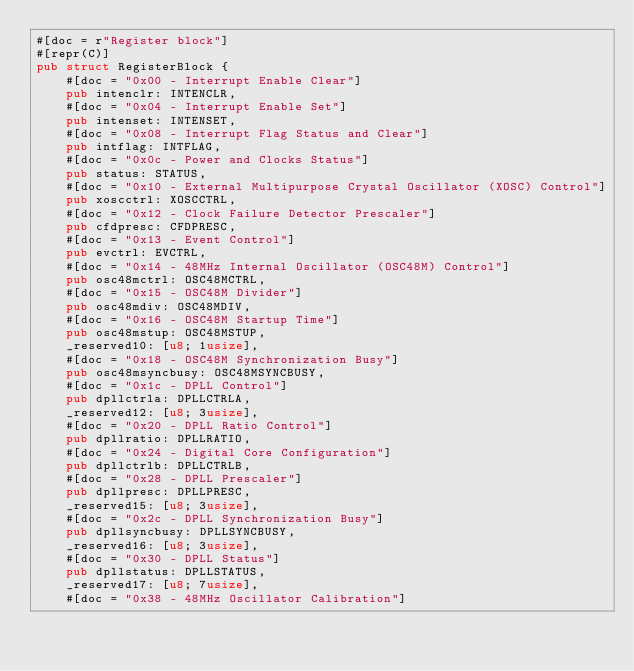<code> <loc_0><loc_0><loc_500><loc_500><_Rust_>#[doc = r"Register block"]
#[repr(C)]
pub struct RegisterBlock {
    #[doc = "0x00 - Interrupt Enable Clear"]
    pub intenclr: INTENCLR,
    #[doc = "0x04 - Interrupt Enable Set"]
    pub intenset: INTENSET,
    #[doc = "0x08 - Interrupt Flag Status and Clear"]
    pub intflag: INTFLAG,
    #[doc = "0x0c - Power and Clocks Status"]
    pub status: STATUS,
    #[doc = "0x10 - External Multipurpose Crystal Oscillator (XOSC) Control"]
    pub xoscctrl: XOSCCTRL,
    #[doc = "0x12 - Clock Failure Detector Prescaler"]
    pub cfdpresc: CFDPRESC,
    #[doc = "0x13 - Event Control"]
    pub evctrl: EVCTRL,
    #[doc = "0x14 - 48MHz Internal Oscillator (OSC48M) Control"]
    pub osc48mctrl: OSC48MCTRL,
    #[doc = "0x15 - OSC48M Divider"]
    pub osc48mdiv: OSC48MDIV,
    #[doc = "0x16 - OSC48M Startup Time"]
    pub osc48mstup: OSC48MSTUP,
    _reserved10: [u8; 1usize],
    #[doc = "0x18 - OSC48M Synchronization Busy"]
    pub osc48msyncbusy: OSC48MSYNCBUSY,
    #[doc = "0x1c - DPLL Control"]
    pub dpllctrla: DPLLCTRLA,
    _reserved12: [u8; 3usize],
    #[doc = "0x20 - DPLL Ratio Control"]
    pub dpllratio: DPLLRATIO,
    #[doc = "0x24 - Digital Core Configuration"]
    pub dpllctrlb: DPLLCTRLB,
    #[doc = "0x28 - DPLL Prescaler"]
    pub dpllpresc: DPLLPRESC,
    _reserved15: [u8; 3usize],
    #[doc = "0x2c - DPLL Synchronization Busy"]
    pub dpllsyncbusy: DPLLSYNCBUSY,
    _reserved16: [u8; 3usize],
    #[doc = "0x30 - DPLL Status"]
    pub dpllstatus: DPLLSTATUS,
    _reserved17: [u8; 7usize],
    #[doc = "0x38 - 48MHz Oscillator Calibration"]</code> 